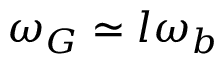Convert formula to latex. <formula><loc_0><loc_0><loc_500><loc_500>\omega _ { G } \simeq l \omega _ { b }</formula> 